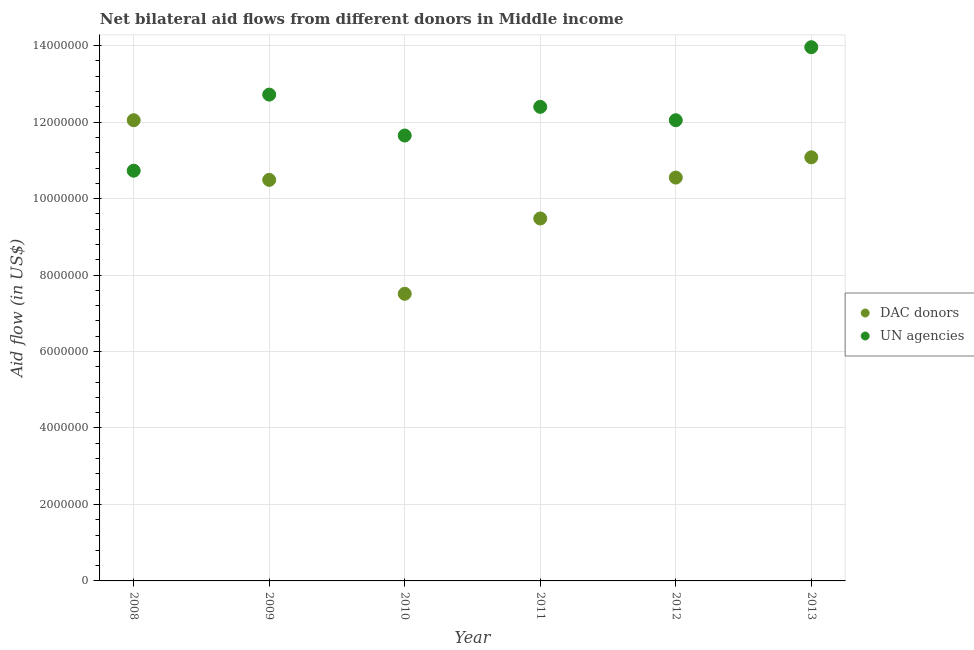How many different coloured dotlines are there?
Provide a short and direct response. 2. Is the number of dotlines equal to the number of legend labels?
Provide a succinct answer. Yes. What is the aid flow from dac donors in 2008?
Make the answer very short. 1.20e+07. Across all years, what is the maximum aid flow from dac donors?
Give a very brief answer. 1.20e+07. Across all years, what is the minimum aid flow from un agencies?
Make the answer very short. 1.07e+07. What is the total aid flow from dac donors in the graph?
Make the answer very short. 6.12e+07. What is the difference between the aid flow from dac donors in 2008 and that in 2011?
Make the answer very short. 2.57e+06. What is the difference between the aid flow from dac donors in 2010 and the aid flow from un agencies in 2008?
Your answer should be compact. -3.22e+06. What is the average aid flow from dac donors per year?
Ensure brevity in your answer.  1.02e+07. In the year 2008, what is the difference between the aid flow from un agencies and aid flow from dac donors?
Make the answer very short. -1.32e+06. In how many years, is the aid flow from un agencies greater than 8400000 US$?
Your response must be concise. 6. What is the ratio of the aid flow from dac donors in 2011 to that in 2012?
Offer a very short reply. 0.9. What is the difference between the highest and the second highest aid flow from un agencies?
Keep it short and to the point. 1.24e+06. What is the difference between the highest and the lowest aid flow from un agencies?
Offer a terse response. 3.23e+06. In how many years, is the aid flow from dac donors greater than the average aid flow from dac donors taken over all years?
Your answer should be very brief. 4. Is the aid flow from dac donors strictly less than the aid flow from un agencies over the years?
Offer a terse response. No. What is the difference between two consecutive major ticks on the Y-axis?
Offer a very short reply. 2.00e+06. What is the title of the graph?
Your answer should be very brief. Net bilateral aid flows from different donors in Middle income. What is the label or title of the Y-axis?
Offer a very short reply. Aid flow (in US$). What is the Aid flow (in US$) in DAC donors in 2008?
Offer a terse response. 1.20e+07. What is the Aid flow (in US$) in UN agencies in 2008?
Provide a short and direct response. 1.07e+07. What is the Aid flow (in US$) of DAC donors in 2009?
Make the answer very short. 1.05e+07. What is the Aid flow (in US$) in UN agencies in 2009?
Give a very brief answer. 1.27e+07. What is the Aid flow (in US$) of DAC donors in 2010?
Your answer should be very brief. 7.51e+06. What is the Aid flow (in US$) of UN agencies in 2010?
Offer a very short reply. 1.16e+07. What is the Aid flow (in US$) in DAC donors in 2011?
Your answer should be compact. 9.48e+06. What is the Aid flow (in US$) of UN agencies in 2011?
Make the answer very short. 1.24e+07. What is the Aid flow (in US$) of DAC donors in 2012?
Offer a very short reply. 1.06e+07. What is the Aid flow (in US$) in UN agencies in 2012?
Ensure brevity in your answer.  1.20e+07. What is the Aid flow (in US$) of DAC donors in 2013?
Offer a terse response. 1.11e+07. What is the Aid flow (in US$) of UN agencies in 2013?
Your answer should be very brief. 1.40e+07. Across all years, what is the maximum Aid flow (in US$) in DAC donors?
Give a very brief answer. 1.20e+07. Across all years, what is the maximum Aid flow (in US$) in UN agencies?
Your answer should be compact. 1.40e+07. Across all years, what is the minimum Aid flow (in US$) of DAC donors?
Offer a terse response. 7.51e+06. Across all years, what is the minimum Aid flow (in US$) of UN agencies?
Your response must be concise. 1.07e+07. What is the total Aid flow (in US$) of DAC donors in the graph?
Provide a succinct answer. 6.12e+07. What is the total Aid flow (in US$) of UN agencies in the graph?
Make the answer very short. 7.35e+07. What is the difference between the Aid flow (in US$) in DAC donors in 2008 and that in 2009?
Your answer should be very brief. 1.56e+06. What is the difference between the Aid flow (in US$) in UN agencies in 2008 and that in 2009?
Keep it short and to the point. -1.99e+06. What is the difference between the Aid flow (in US$) in DAC donors in 2008 and that in 2010?
Offer a very short reply. 4.54e+06. What is the difference between the Aid flow (in US$) in UN agencies in 2008 and that in 2010?
Keep it short and to the point. -9.20e+05. What is the difference between the Aid flow (in US$) of DAC donors in 2008 and that in 2011?
Offer a terse response. 2.57e+06. What is the difference between the Aid flow (in US$) in UN agencies in 2008 and that in 2011?
Provide a succinct answer. -1.67e+06. What is the difference between the Aid flow (in US$) in DAC donors in 2008 and that in 2012?
Your answer should be very brief. 1.50e+06. What is the difference between the Aid flow (in US$) of UN agencies in 2008 and that in 2012?
Provide a succinct answer. -1.32e+06. What is the difference between the Aid flow (in US$) of DAC donors in 2008 and that in 2013?
Offer a terse response. 9.70e+05. What is the difference between the Aid flow (in US$) in UN agencies in 2008 and that in 2013?
Ensure brevity in your answer.  -3.23e+06. What is the difference between the Aid flow (in US$) of DAC donors in 2009 and that in 2010?
Offer a terse response. 2.98e+06. What is the difference between the Aid flow (in US$) in UN agencies in 2009 and that in 2010?
Provide a short and direct response. 1.07e+06. What is the difference between the Aid flow (in US$) in DAC donors in 2009 and that in 2011?
Offer a terse response. 1.01e+06. What is the difference between the Aid flow (in US$) of UN agencies in 2009 and that in 2012?
Provide a short and direct response. 6.70e+05. What is the difference between the Aid flow (in US$) in DAC donors in 2009 and that in 2013?
Offer a very short reply. -5.90e+05. What is the difference between the Aid flow (in US$) of UN agencies in 2009 and that in 2013?
Provide a succinct answer. -1.24e+06. What is the difference between the Aid flow (in US$) in DAC donors in 2010 and that in 2011?
Your answer should be compact. -1.97e+06. What is the difference between the Aid flow (in US$) in UN agencies in 2010 and that in 2011?
Offer a terse response. -7.50e+05. What is the difference between the Aid flow (in US$) of DAC donors in 2010 and that in 2012?
Your answer should be compact. -3.04e+06. What is the difference between the Aid flow (in US$) of UN agencies in 2010 and that in 2012?
Give a very brief answer. -4.00e+05. What is the difference between the Aid flow (in US$) of DAC donors in 2010 and that in 2013?
Give a very brief answer. -3.57e+06. What is the difference between the Aid flow (in US$) in UN agencies in 2010 and that in 2013?
Make the answer very short. -2.31e+06. What is the difference between the Aid flow (in US$) in DAC donors in 2011 and that in 2012?
Offer a very short reply. -1.07e+06. What is the difference between the Aid flow (in US$) of UN agencies in 2011 and that in 2012?
Provide a short and direct response. 3.50e+05. What is the difference between the Aid flow (in US$) in DAC donors in 2011 and that in 2013?
Ensure brevity in your answer.  -1.60e+06. What is the difference between the Aid flow (in US$) of UN agencies in 2011 and that in 2013?
Provide a short and direct response. -1.56e+06. What is the difference between the Aid flow (in US$) of DAC donors in 2012 and that in 2013?
Provide a short and direct response. -5.30e+05. What is the difference between the Aid flow (in US$) in UN agencies in 2012 and that in 2013?
Give a very brief answer. -1.91e+06. What is the difference between the Aid flow (in US$) of DAC donors in 2008 and the Aid flow (in US$) of UN agencies in 2009?
Ensure brevity in your answer.  -6.70e+05. What is the difference between the Aid flow (in US$) in DAC donors in 2008 and the Aid flow (in US$) in UN agencies in 2010?
Offer a terse response. 4.00e+05. What is the difference between the Aid flow (in US$) of DAC donors in 2008 and the Aid flow (in US$) of UN agencies in 2011?
Offer a terse response. -3.50e+05. What is the difference between the Aid flow (in US$) in DAC donors in 2008 and the Aid flow (in US$) in UN agencies in 2012?
Your answer should be compact. 0. What is the difference between the Aid flow (in US$) of DAC donors in 2008 and the Aid flow (in US$) of UN agencies in 2013?
Your answer should be very brief. -1.91e+06. What is the difference between the Aid flow (in US$) of DAC donors in 2009 and the Aid flow (in US$) of UN agencies in 2010?
Provide a succinct answer. -1.16e+06. What is the difference between the Aid flow (in US$) of DAC donors in 2009 and the Aid flow (in US$) of UN agencies in 2011?
Your answer should be compact. -1.91e+06. What is the difference between the Aid flow (in US$) in DAC donors in 2009 and the Aid flow (in US$) in UN agencies in 2012?
Offer a very short reply. -1.56e+06. What is the difference between the Aid flow (in US$) of DAC donors in 2009 and the Aid flow (in US$) of UN agencies in 2013?
Your answer should be very brief. -3.47e+06. What is the difference between the Aid flow (in US$) in DAC donors in 2010 and the Aid flow (in US$) in UN agencies in 2011?
Give a very brief answer. -4.89e+06. What is the difference between the Aid flow (in US$) of DAC donors in 2010 and the Aid flow (in US$) of UN agencies in 2012?
Provide a short and direct response. -4.54e+06. What is the difference between the Aid flow (in US$) in DAC donors in 2010 and the Aid flow (in US$) in UN agencies in 2013?
Provide a succinct answer. -6.45e+06. What is the difference between the Aid flow (in US$) in DAC donors in 2011 and the Aid flow (in US$) in UN agencies in 2012?
Offer a very short reply. -2.57e+06. What is the difference between the Aid flow (in US$) of DAC donors in 2011 and the Aid flow (in US$) of UN agencies in 2013?
Give a very brief answer. -4.48e+06. What is the difference between the Aid flow (in US$) of DAC donors in 2012 and the Aid flow (in US$) of UN agencies in 2013?
Keep it short and to the point. -3.41e+06. What is the average Aid flow (in US$) in DAC donors per year?
Provide a short and direct response. 1.02e+07. What is the average Aid flow (in US$) in UN agencies per year?
Your answer should be very brief. 1.23e+07. In the year 2008, what is the difference between the Aid flow (in US$) of DAC donors and Aid flow (in US$) of UN agencies?
Your response must be concise. 1.32e+06. In the year 2009, what is the difference between the Aid flow (in US$) in DAC donors and Aid flow (in US$) in UN agencies?
Provide a succinct answer. -2.23e+06. In the year 2010, what is the difference between the Aid flow (in US$) of DAC donors and Aid flow (in US$) of UN agencies?
Provide a short and direct response. -4.14e+06. In the year 2011, what is the difference between the Aid flow (in US$) in DAC donors and Aid flow (in US$) in UN agencies?
Ensure brevity in your answer.  -2.92e+06. In the year 2012, what is the difference between the Aid flow (in US$) in DAC donors and Aid flow (in US$) in UN agencies?
Offer a terse response. -1.50e+06. In the year 2013, what is the difference between the Aid flow (in US$) of DAC donors and Aid flow (in US$) of UN agencies?
Give a very brief answer. -2.88e+06. What is the ratio of the Aid flow (in US$) of DAC donors in 2008 to that in 2009?
Make the answer very short. 1.15. What is the ratio of the Aid flow (in US$) in UN agencies in 2008 to that in 2009?
Your answer should be very brief. 0.84. What is the ratio of the Aid flow (in US$) in DAC donors in 2008 to that in 2010?
Your answer should be very brief. 1.6. What is the ratio of the Aid flow (in US$) of UN agencies in 2008 to that in 2010?
Offer a terse response. 0.92. What is the ratio of the Aid flow (in US$) of DAC donors in 2008 to that in 2011?
Make the answer very short. 1.27. What is the ratio of the Aid flow (in US$) in UN agencies in 2008 to that in 2011?
Give a very brief answer. 0.87. What is the ratio of the Aid flow (in US$) of DAC donors in 2008 to that in 2012?
Give a very brief answer. 1.14. What is the ratio of the Aid flow (in US$) of UN agencies in 2008 to that in 2012?
Make the answer very short. 0.89. What is the ratio of the Aid flow (in US$) in DAC donors in 2008 to that in 2013?
Provide a succinct answer. 1.09. What is the ratio of the Aid flow (in US$) in UN agencies in 2008 to that in 2013?
Provide a short and direct response. 0.77. What is the ratio of the Aid flow (in US$) of DAC donors in 2009 to that in 2010?
Offer a terse response. 1.4. What is the ratio of the Aid flow (in US$) in UN agencies in 2009 to that in 2010?
Offer a terse response. 1.09. What is the ratio of the Aid flow (in US$) of DAC donors in 2009 to that in 2011?
Your answer should be compact. 1.11. What is the ratio of the Aid flow (in US$) in UN agencies in 2009 to that in 2011?
Give a very brief answer. 1.03. What is the ratio of the Aid flow (in US$) in DAC donors in 2009 to that in 2012?
Keep it short and to the point. 0.99. What is the ratio of the Aid flow (in US$) in UN agencies in 2009 to that in 2012?
Your answer should be compact. 1.06. What is the ratio of the Aid flow (in US$) of DAC donors in 2009 to that in 2013?
Keep it short and to the point. 0.95. What is the ratio of the Aid flow (in US$) of UN agencies in 2009 to that in 2013?
Give a very brief answer. 0.91. What is the ratio of the Aid flow (in US$) of DAC donors in 2010 to that in 2011?
Provide a succinct answer. 0.79. What is the ratio of the Aid flow (in US$) in UN agencies in 2010 to that in 2011?
Keep it short and to the point. 0.94. What is the ratio of the Aid flow (in US$) in DAC donors in 2010 to that in 2012?
Your response must be concise. 0.71. What is the ratio of the Aid flow (in US$) in UN agencies in 2010 to that in 2012?
Offer a very short reply. 0.97. What is the ratio of the Aid flow (in US$) of DAC donors in 2010 to that in 2013?
Ensure brevity in your answer.  0.68. What is the ratio of the Aid flow (in US$) in UN agencies in 2010 to that in 2013?
Offer a terse response. 0.83. What is the ratio of the Aid flow (in US$) of DAC donors in 2011 to that in 2012?
Your answer should be very brief. 0.9. What is the ratio of the Aid flow (in US$) in UN agencies in 2011 to that in 2012?
Keep it short and to the point. 1.03. What is the ratio of the Aid flow (in US$) in DAC donors in 2011 to that in 2013?
Make the answer very short. 0.86. What is the ratio of the Aid flow (in US$) in UN agencies in 2011 to that in 2013?
Your answer should be compact. 0.89. What is the ratio of the Aid flow (in US$) of DAC donors in 2012 to that in 2013?
Your response must be concise. 0.95. What is the ratio of the Aid flow (in US$) of UN agencies in 2012 to that in 2013?
Ensure brevity in your answer.  0.86. What is the difference between the highest and the second highest Aid flow (in US$) of DAC donors?
Offer a terse response. 9.70e+05. What is the difference between the highest and the second highest Aid flow (in US$) of UN agencies?
Provide a short and direct response. 1.24e+06. What is the difference between the highest and the lowest Aid flow (in US$) in DAC donors?
Your answer should be compact. 4.54e+06. What is the difference between the highest and the lowest Aid flow (in US$) of UN agencies?
Your answer should be compact. 3.23e+06. 